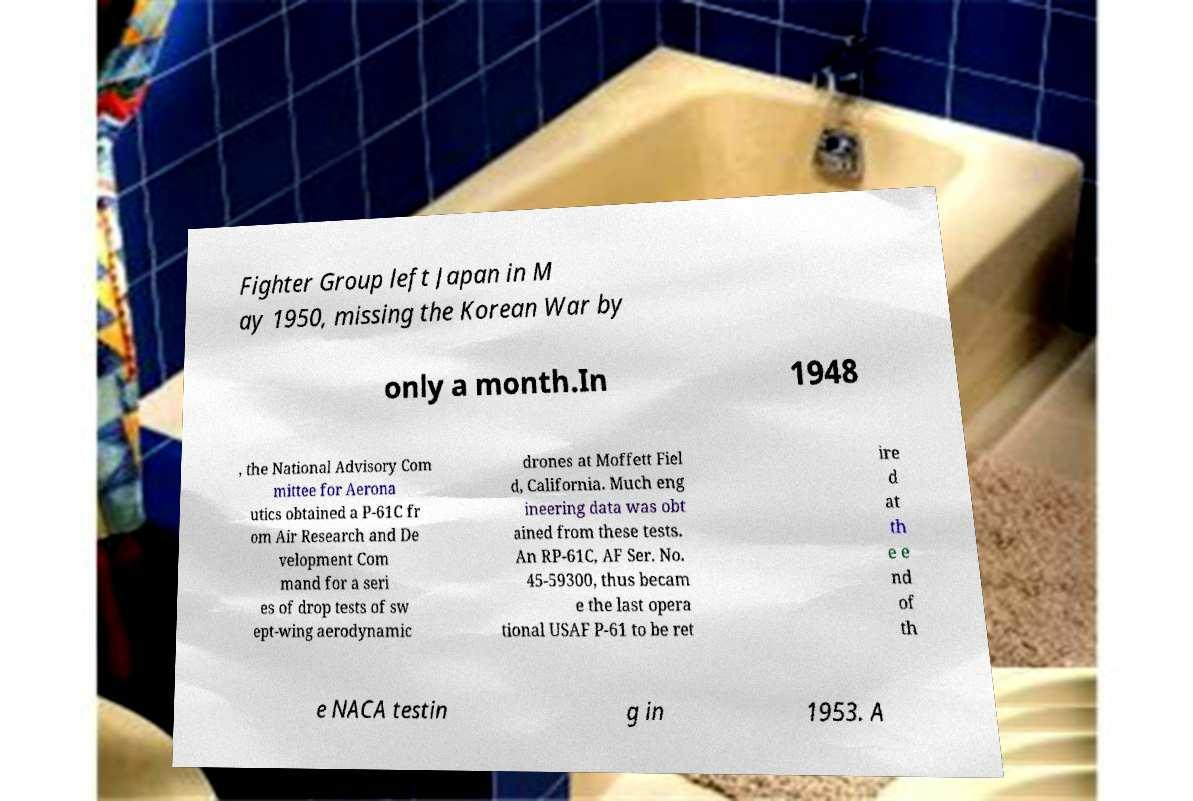Please identify and transcribe the text found in this image. Fighter Group left Japan in M ay 1950, missing the Korean War by only a month.In 1948 , the National Advisory Com mittee for Aerona utics obtained a P-61C fr om Air Research and De velopment Com mand for a seri es of drop tests of sw ept-wing aerodynamic drones at Moffett Fiel d, California. Much eng ineering data was obt ained from these tests. An RP-61C, AF Ser. No. 45-59300, thus becam e the last opera tional USAF P-61 to be ret ire d at th e e nd of th e NACA testin g in 1953. A 